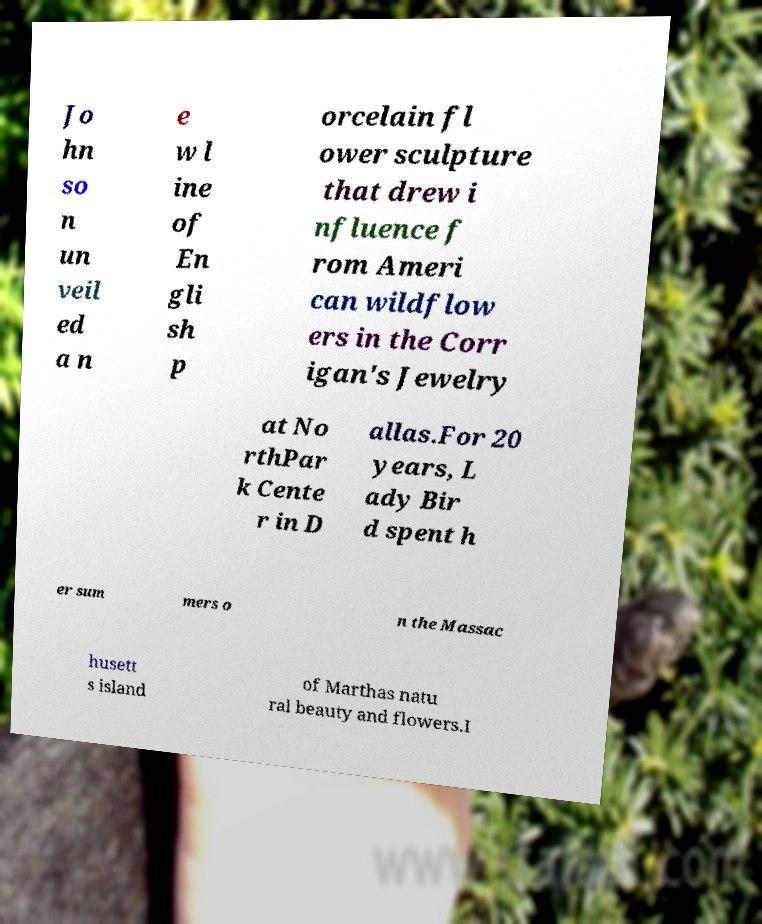Can you read and provide the text displayed in the image?This photo seems to have some interesting text. Can you extract and type it out for me? Jo hn so n un veil ed a n e w l ine of En gli sh p orcelain fl ower sculpture that drew i nfluence f rom Ameri can wildflow ers in the Corr igan's Jewelry at No rthPar k Cente r in D allas.For 20 years, L ady Bir d spent h er sum mers o n the Massac husett s island of Marthas natu ral beauty and flowers.I 